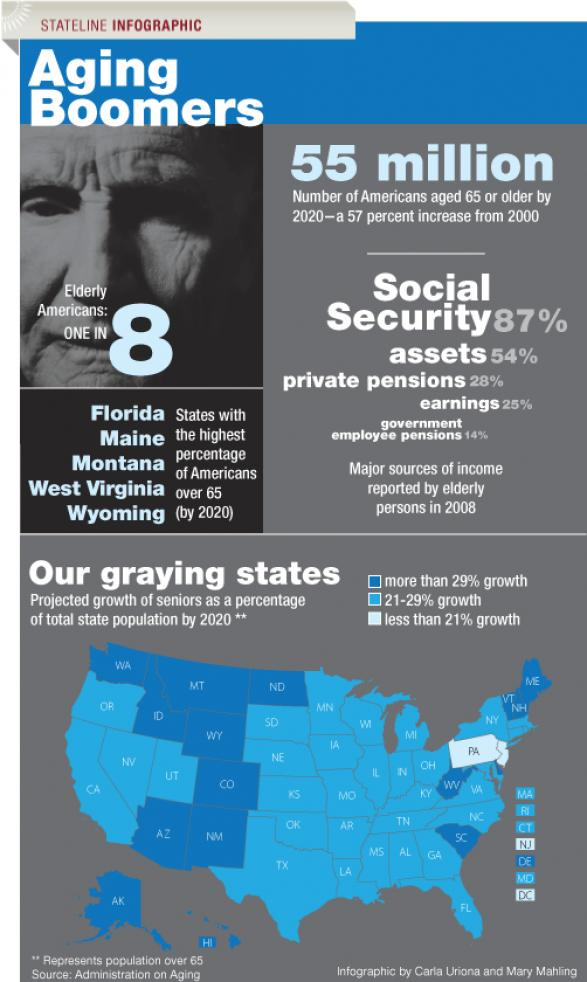Point out several critical features in this image. The difference between earnings and government employee pensions is that earnings are a portion of an employee's salary that is withheld for retirement savings, while government employee pensions are retirement benefits provided by the government to employees upon retirement. The difference between social security and assets is 33%. Private pensions and earnings differ in that private pensions typically provide a guaranteed income in retirement, while earnings are the compensation an individual receives for their work. The difference between assets and private pensions is 26%. 